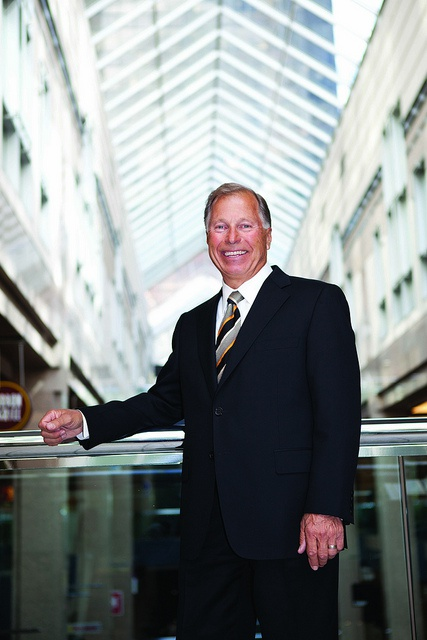Describe the objects in this image and their specific colors. I can see people in lightgray, black, brown, white, and lightpink tones and tie in lightgray, black, darkgray, and gray tones in this image. 